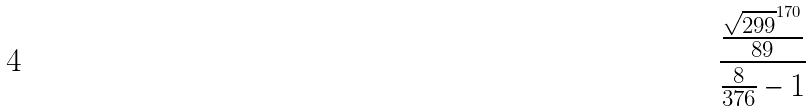Convert formula to latex. <formula><loc_0><loc_0><loc_500><loc_500>\frac { \frac { \sqrt { 2 9 9 } ^ { 1 7 0 } } { 8 9 } } { \frac { 8 } { 3 7 6 } - 1 }</formula> 